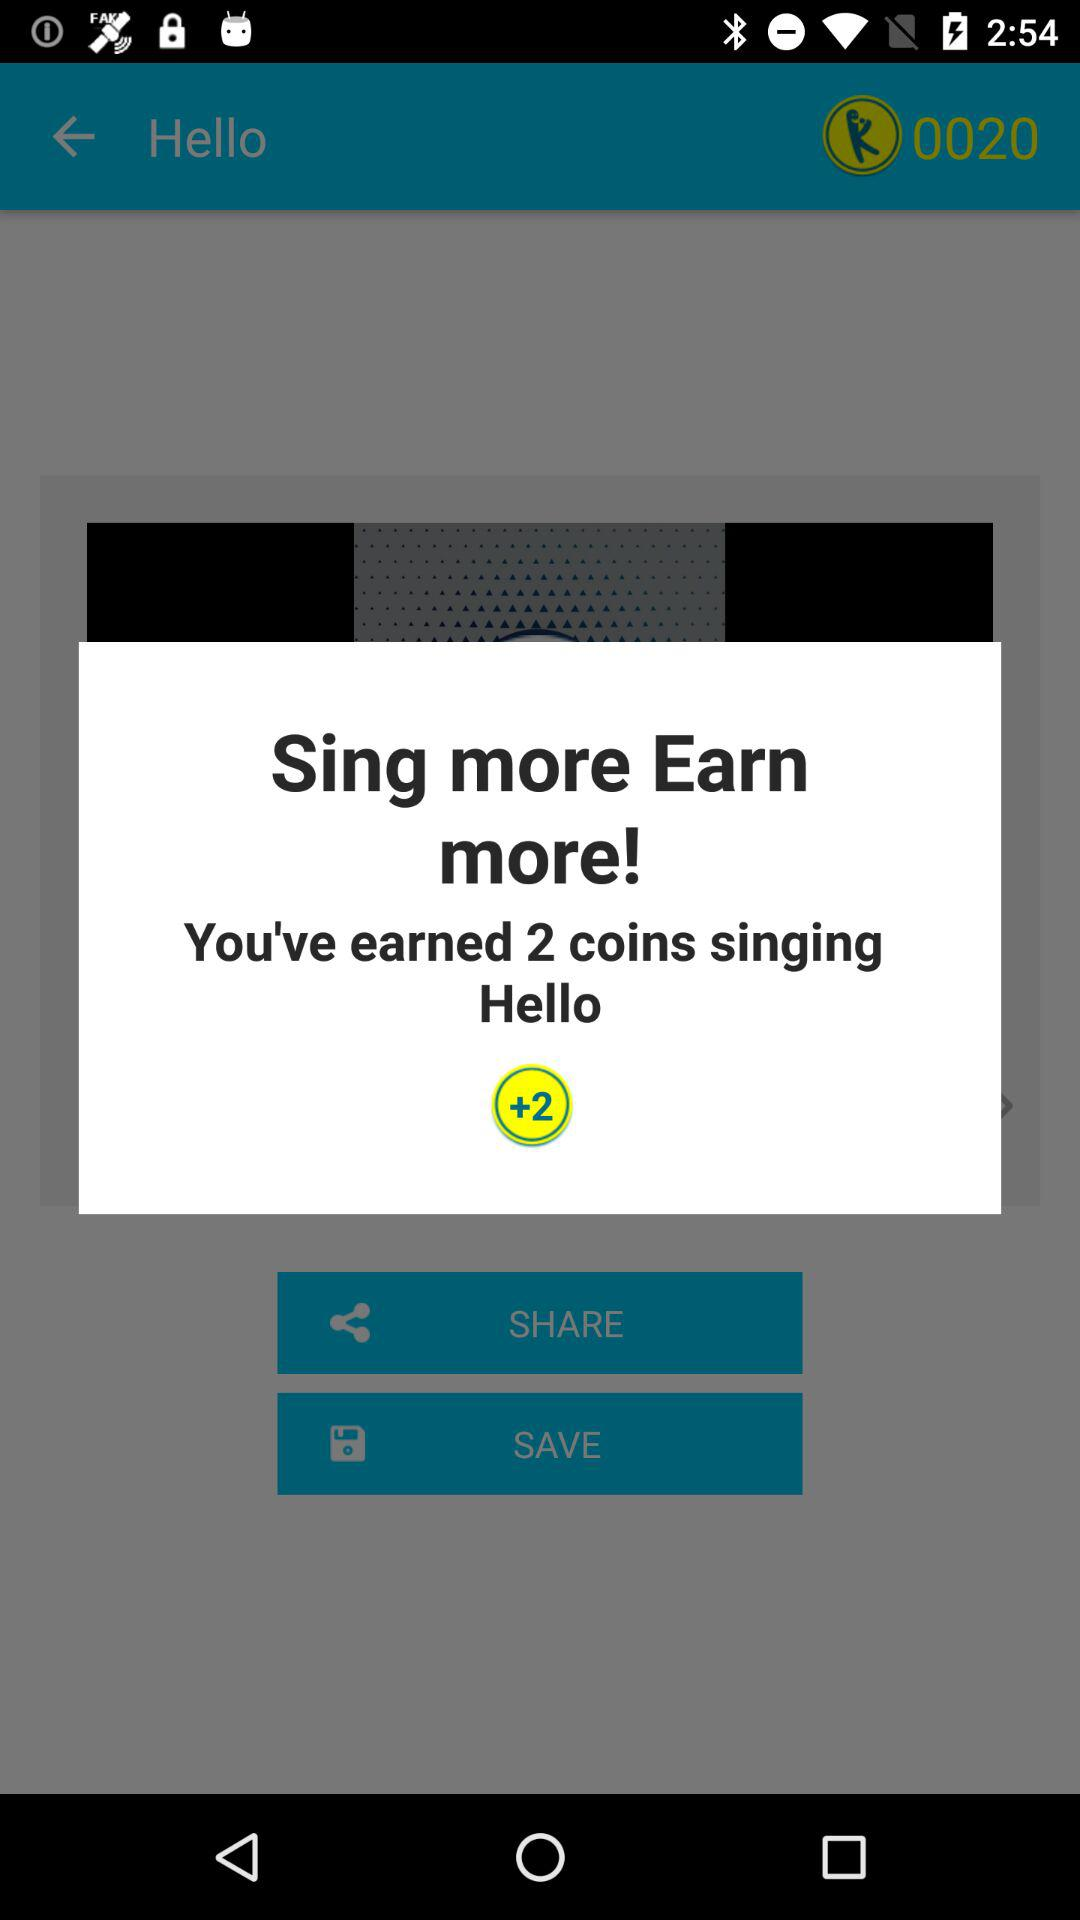How many coins did I earn in total?
Answer the question using a single word or phrase. 2 